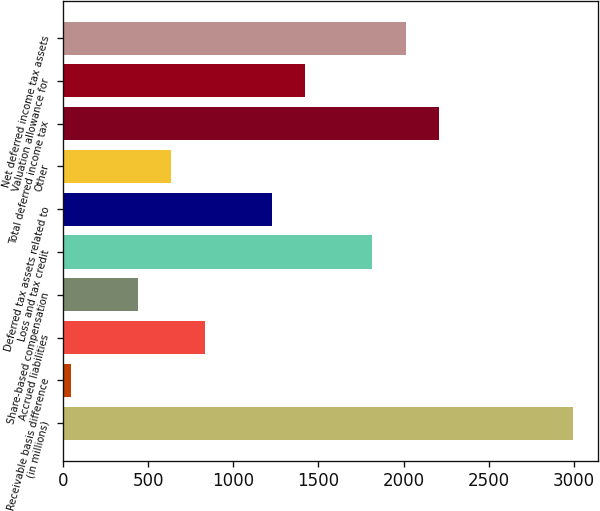<chart> <loc_0><loc_0><loc_500><loc_500><bar_chart><fcel>(in millions)<fcel>Receivable basis difference<fcel>Accrued liabilities<fcel>Share-based compensation<fcel>Loss and tax credit<fcel>Deferred tax assets related to<fcel>Other<fcel>Total deferred income tax<fcel>Valuation allowance for<fcel>Net deferred income tax assets<nl><fcel>2993.5<fcel>46<fcel>832<fcel>439<fcel>1814.5<fcel>1225<fcel>635.5<fcel>2207.5<fcel>1421.5<fcel>2011<nl></chart> 